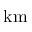Convert formula to latex. <formula><loc_0><loc_0><loc_500><loc_500>k m</formula> 